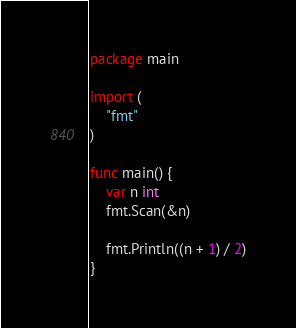Convert code to text. <code><loc_0><loc_0><loc_500><loc_500><_Go_>package main

import (
	"fmt"
)

func main() {
	var n int
	fmt.Scan(&n)

	fmt.Println((n + 1) / 2)
}
</code> 